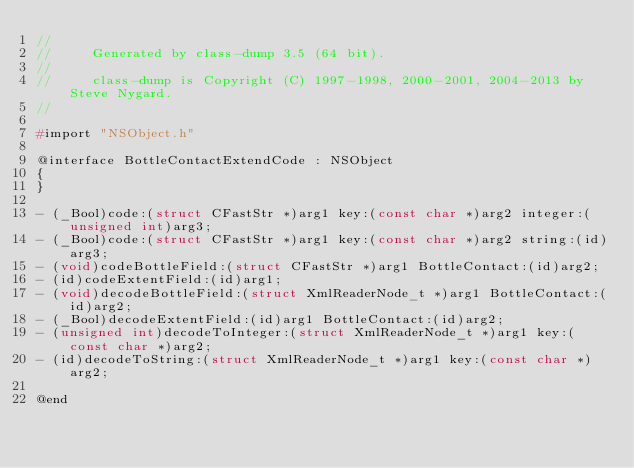<code> <loc_0><loc_0><loc_500><loc_500><_C_>//
//     Generated by class-dump 3.5 (64 bit).
//
//     class-dump is Copyright (C) 1997-1998, 2000-2001, 2004-2013 by Steve Nygard.
//

#import "NSObject.h"

@interface BottleContactExtendCode : NSObject
{
}

- (_Bool)code:(struct CFastStr *)arg1 key:(const char *)arg2 integer:(unsigned int)arg3;
- (_Bool)code:(struct CFastStr *)arg1 key:(const char *)arg2 string:(id)arg3;
- (void)codeBottleField:(struct CFastStr *)arg1 BottleContact:(id)arg2;
- (id)codeExtentField:(id)arg1;
- (void)decodeBottleField:(struct XmlReaderNode_t *)arg1 BottleContact:(id)arg2;
- (_Bool)decodeExtentField:(id)arg1 BottleContact:(id)arg2;
- (unsigned int)decodeToInteger:(struct XmlReaderNode_t *)arg1 key:(const char *)arg2;
- (id)decodeToString:(struct XmlReaderNode_t *)arg1 key:(const char *)arg2;

@end

</code> 